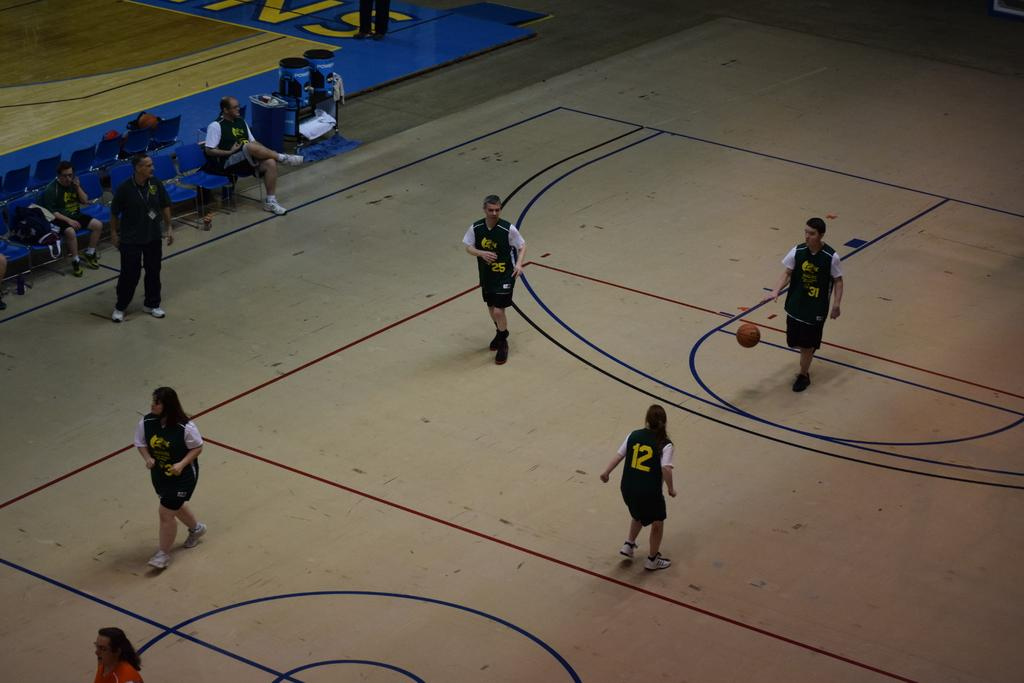<image>
Give a short and clear explanation of the subsequent image. Player number 31 dribbles a basketball while player number 12 defends. 